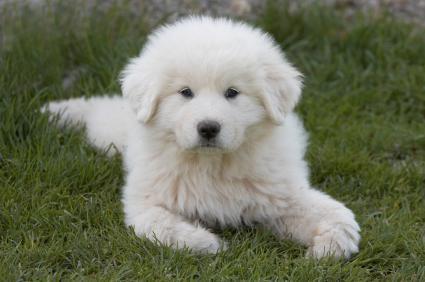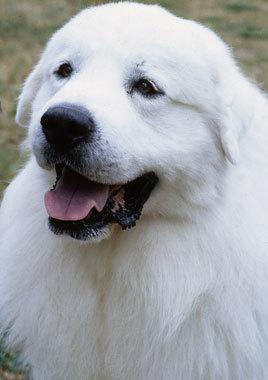The first image is the image on the left, the second image is the image on the right. Examine the images to the left and right. Is the description "All images show one dog that is standing." accurate? Answer yes or no. No. The first image is the image on the left, the second image is the image on the right. Analyze the images presented: Is the assertion "All images show one adult dog standing still outdoors." valid? Answer yes or no. No. 